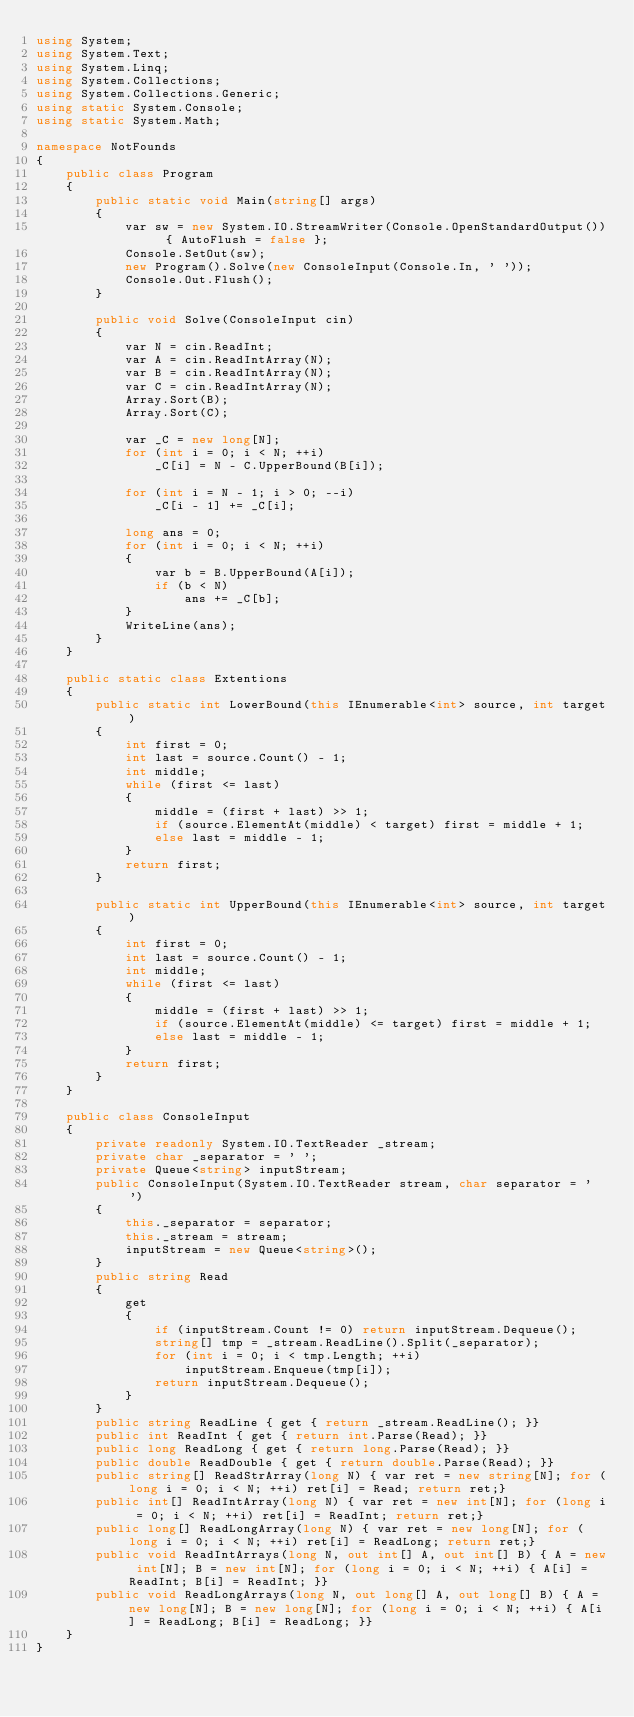<code> <loc_0><loc_0><loc_500><loc_500><_C#_>using System;
using System.Text;
using System.Linq;
using System.Collections;
using System.Collections.Generic;
using static System.Console;
using static System.Math;

namespace NotFounds
{
    public class Program
    {
        public static void Main(string[] args)
        {
            var sw = new System.IO.StreamWriter(Console.OpenStandardOutput()) { AutoFlush = false };
            Console.SetOut(sw);
            new Program().Solve(new ConsoleInput(Console.In, ' '));
            Console.Out.Flush();
        }

        public void Solve(ConsoleInput cin)
        {
            var N = cin.ReadInt;
            var A = cin.ReadIntArray(N);
            var B = cin.ReadIntArray(N);
            var C = cin.ReadIntArray(N);
            Array.Sort(B);
            Array.Sort(C);

            var _C = new long[N];
            for (int i = 0; i < N; ++i)
                _C[i] = N - C.UpperBound(B[i]);

            for (int i = N - 1; i > 0; --i)
                _C[i - 1] += _C[i];

            long ans = 0;
            for (int i = 0; i < N; ++i)
            {
                var b = B.UpperBound(A[i]);
                if (b < N)
                    ans += _C[b];
            }
            WriteLine(ans);
        }
    }

    public static class Extentions
    {
        public static int LowerBound(this IEnumerable<int> source, int target)
        {
            int first = 0;
            int last = source.Count() - 1;
            int middle;
            while (first <= last)
            {
                middle = (first + last) >> 1;
                if (source.ElementAt(middle) < target) first = middle + 1;
                else last = middle - 1;
            }
            return first;
        }

        public static int UpperBound(this IEnumerable<int> source, int target)
        {
            int first = 0;
            int last = source.Count() - 1;
            int middle;
            while (first <= last)
            {
                middle = (first + last) >> 1;
                if (source.ElementAt(middle) <= target) first = middle + 1;
                else last = middle - 1;
            }
            return first;
        }
    }

    public class ConsoleInput
    {
        private readonly System.IO.TextReader _stream;
        private char _separator = ' ';
        private Queue<string> inputStream;
        public ConsoleInput(System.IO.TextReader stream, char separator = ' ')
        {
            this._separator = separator;
            this._stream = stream;
            inputStream = new Queue<string>();
        }
        public string Read
        {
            get
            {
                if (inputStream.Count != 0) return inputStream.Dequeue();
                string[] tmp = _stream.ReadLine().Split(_separator);
                for (int i = 0; i < tmp.Length; ++i)
                    inputStream.Enqueue(tmp[i]);
                return inputStream.Dequeue();
            }
        }
        public string ReadLine { get { return _stream.ReadLine(); }}
        public int ReadInt { get { return int.Parse(Read); }}
        public long ReadLong { get { return long.Parse(Read); }}
        public double ReadDouble { get { return double.Parse(Read); }}
        public string[] ReadStrArray(long N) { var ret = new string[N]; for (long i = 0; i < N; ++i) ret[i] = Read; return ret;}
        public int[] ReadIntArray(long N) { var ret = new int[N]; for (long i = 0; i < N; ++i) ret[i] = ReadInt; return ret;}
        public long[] ReadLongArray(long N) { var ret = new long[N]; for (long i = 0; i < N; ++i) ret[i] = ReadLong; return ret;}
        public void ReadIntArrays(long N, out int[] A, out int[] B) { A = new int[N]; B = new int[N]; for (long i = 0; i < N; ++i) { A[i] = ReadInt; B[i] = ReadInt; }}
        public void ReadLongArrays(long N, out long[] A, out long[] B) { A = new long[N]; B = new long[N]; for (long i = 0; i < N; ++i) { A[i] = ReadLong; B[i] = ReadLong; }}
    }
}
</code> 